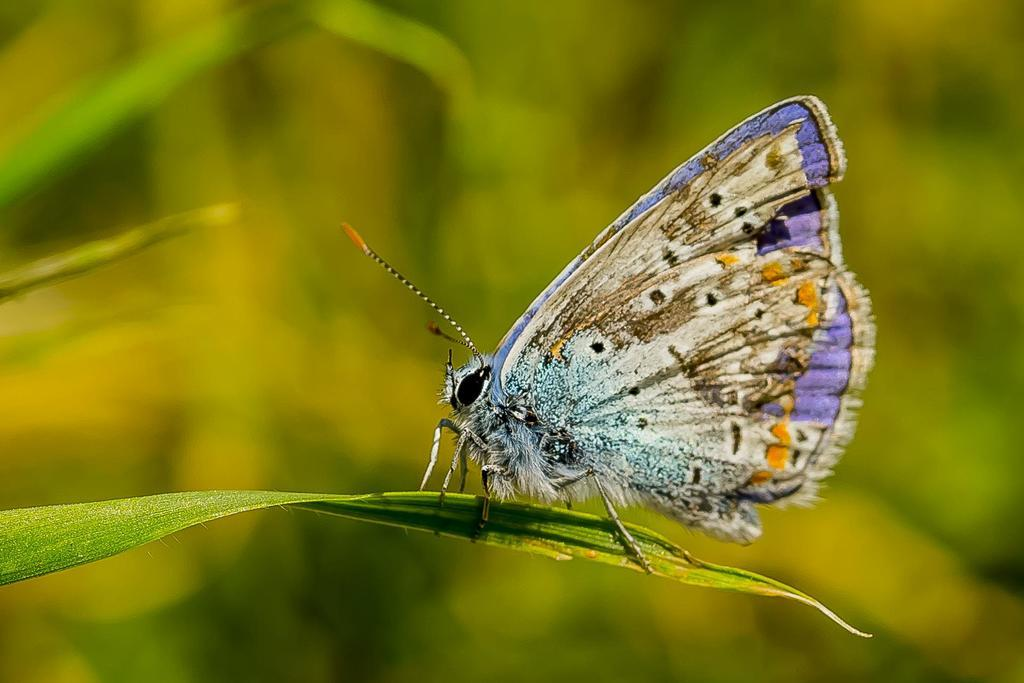What is the main subject of the image? There is a butterfly in the image. Where is the butterfly located? The butterfly is on a plant. What is the position of the butterfly and plant in the image? The butterfly and plant are in the center of the image. What route does the doll take to reach the spring in the image? There is no doll or spring present in the image; it only features a butterfly on a plant. 